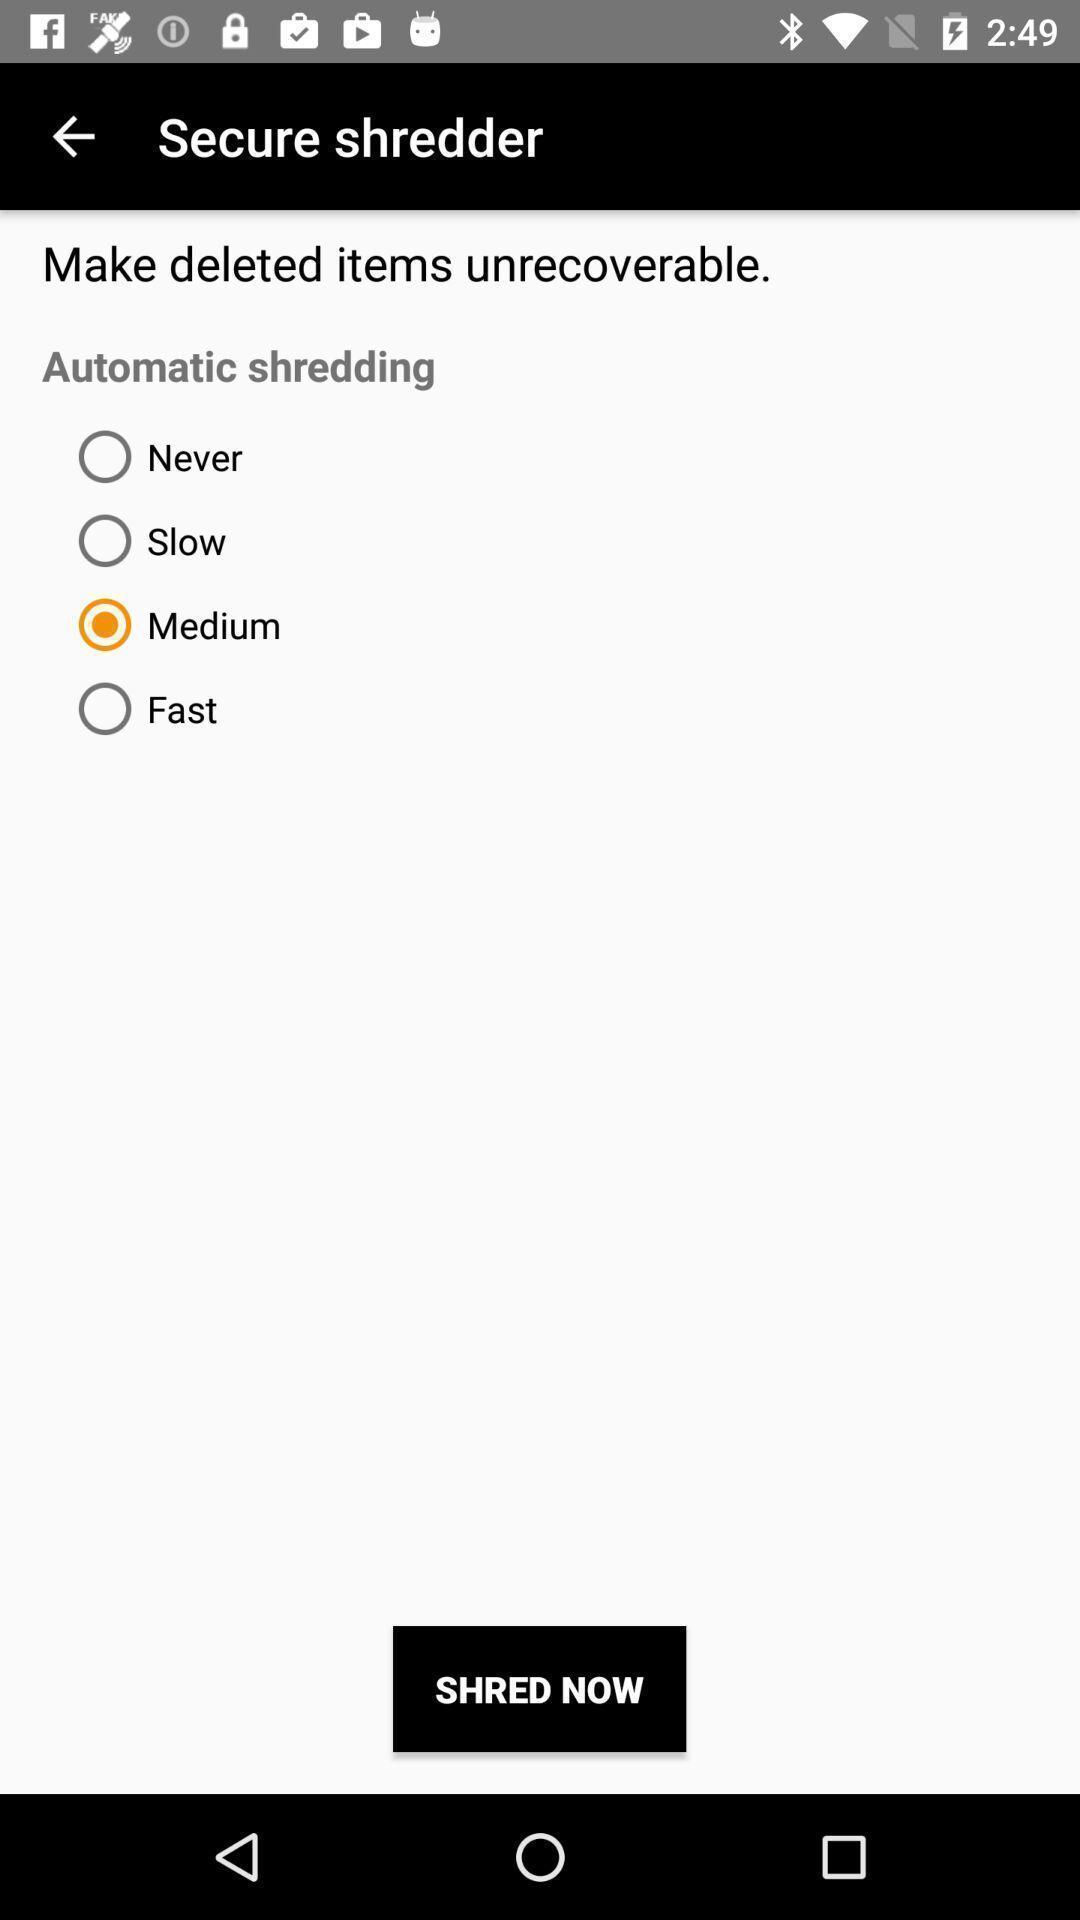Provide a detailed account of this screenshot. Page displaying options with radio buttons. 